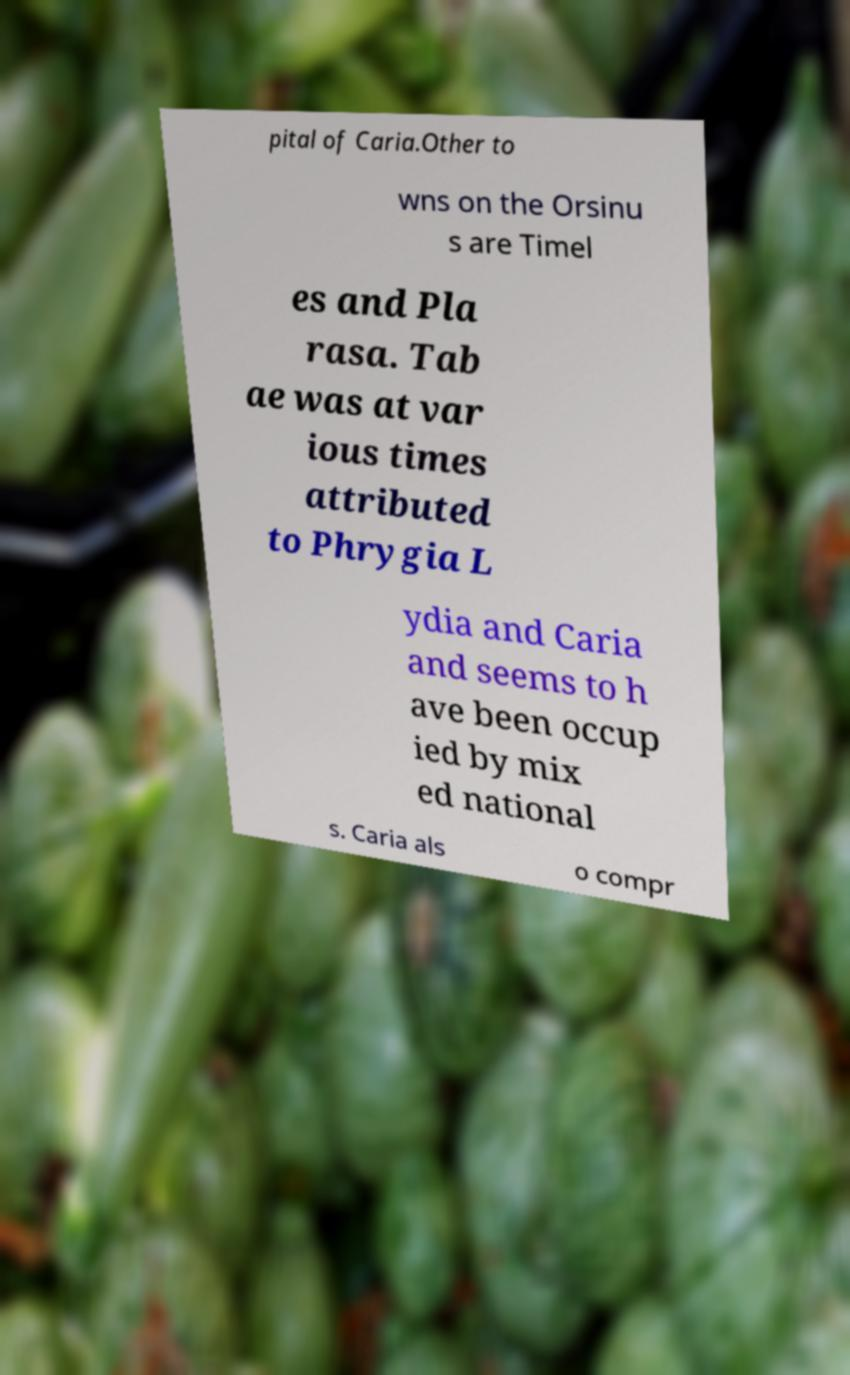Please identify and transcribe the text found in this image. pital of Caria.Other to wns on the Orsinu s are Timel es and Pla rasa. Tab ae was at var ious times attributed to Phrygia L ydia and Caria and seems to h ave been occup ied by mix ed national s. Caria als o compr 